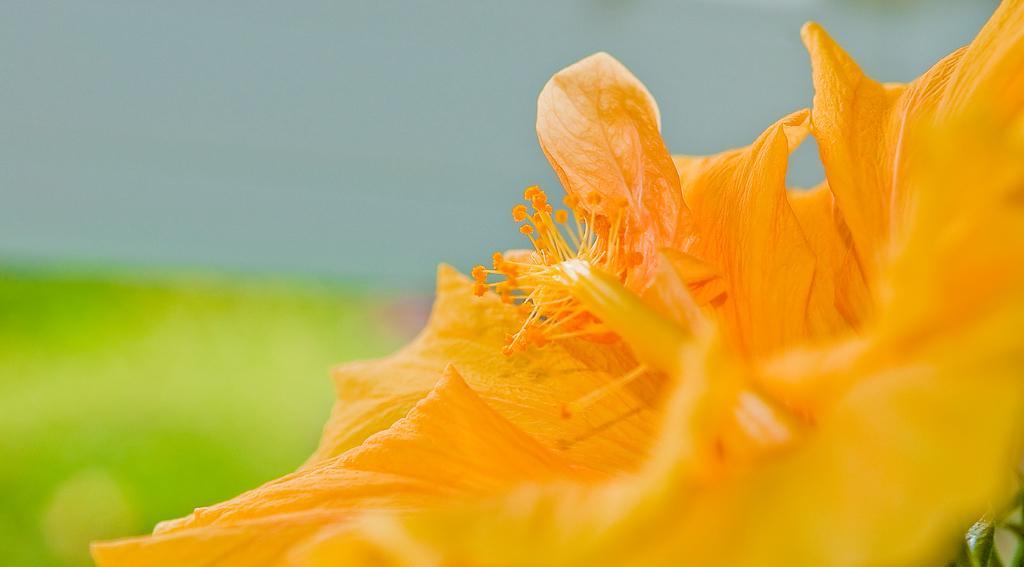In one or two sentences, can you explain what this image depicts? In this image I can see a orange flower. Background is in green and blue color. 